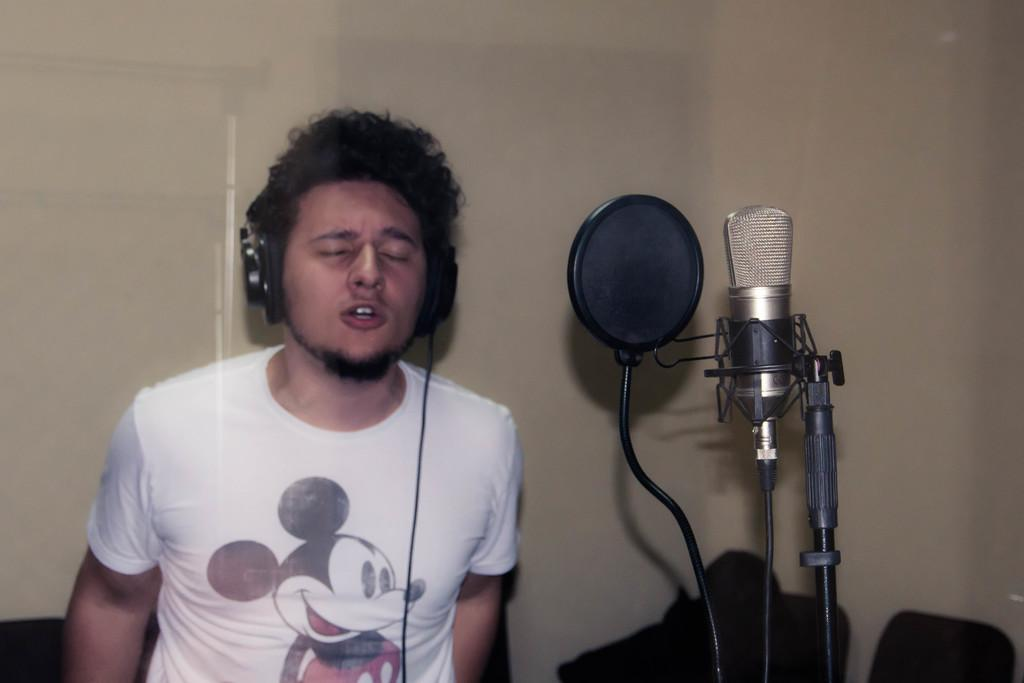What is the main subject of the image? There is a person standing in the center of the image. What is the person wearing in the image? The person is wearing a headset in the image. What can be seen on the right side of the image? There is a microphone (mic) on the right side of the image. What is visible in the background of the image? There is a wall in the background of the image. What color is the judge's robe in the image? There is no judge or robe present in the image; it features a person wearing a headset and a microphone. How many cords are connected to the microphone in the image? There is no visible cord connected to the microphone in the image. 